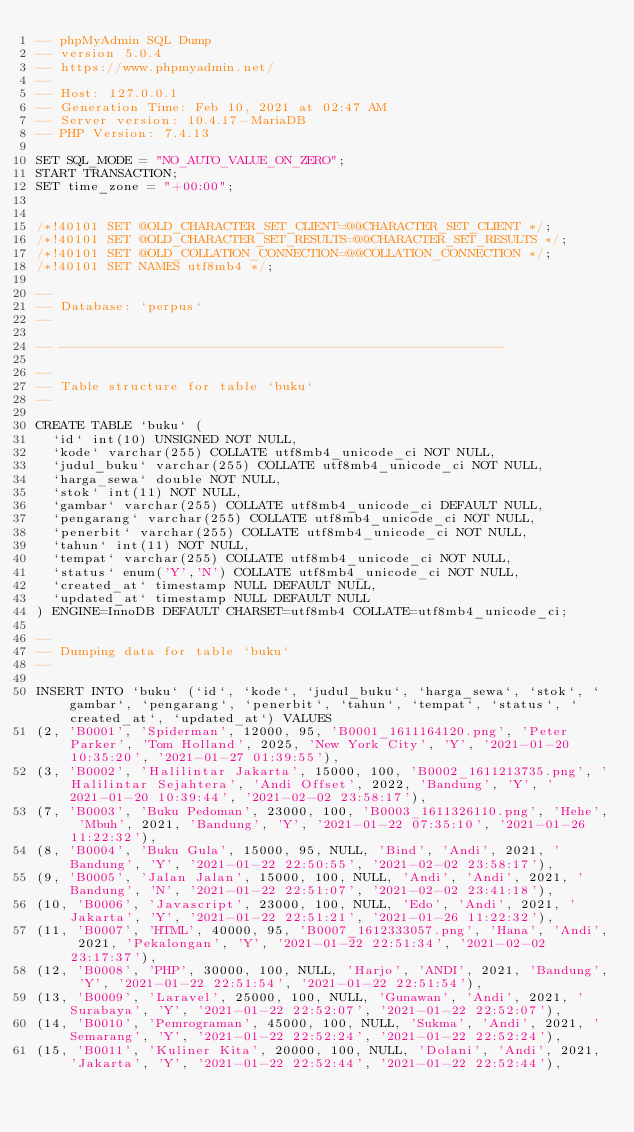Convert code to text. <code><loc_0><loc_0><loc_500><loc_500><_SQL_>-- phpMyAdmin SQL Dump
-- version 5.0.4
-- https://www.phpmyadmin.net/
--
-- Host: 127.0.0.1
-- Generation Time: Feb 10, 2021 at 02:47 AM
-- Server version: 10.4.17-MariaDB
-- PHP Version: 7.4.13

SET SQL_MODE = "NO_AUTO_VALUE_ON_ZERO";
START TRANSACTION;
SET time_zone = "+00:00";


/*!40101 SET @OLD_CHARACTER_SET_CLIENT=@@CHARACTER_SET_CLIENT */;
/*!40101 SET @OLD_CHARACTER_SET_RESULTS=@@CHARACTER_SET_RESULTS */;
/*!40101 SET @OLD_COLLATION_CONNECTION=@@COLLATION_CONNECTION */;
/*!40101 SET NAMES utf8mb4 */;

--
-- Database: `perpus`
--

-- --------------------------------------------------------

--
-- Table structure for table `buku`
--

CREATE TABLE `buku` (
  `id` int(10) UNSIGNED NOT NULL,
  `kode` varchar(255) COLLATE utf8mb4_unicode_ci NOT NULL,
  `judul_buku` varchar(255) COLLATE utf8mb4_unicode_ci NOT NULL,
  `harga_sewa` double NOT NULL,
  `stok` int(11) NOT NULL,
  `gambar` varchar(255) COLLATE utf8mb4_unicode_ci DEFAULT NULL,
  `pengarang` varchar(255) COLLATE utf8mb4_unicode_ci NOT NULL,
  `penerbit` varchar(255) COLLATE utf8mb4_unicode_ci NOT NULL,
  `tahun` int(11) NOT NULL,
  `tempat` varchar(255) COLLATE utf8mb4_unicode_ci NOT NULL,
  `status` enum('Y','N') COLLATE utf8mb4_unicode_ci NOT NULL,
  `created_at` timestamp NULL DEFAULT NULL,
  `updated_at` timestamp NULL DEFAULT NULL
) ENGINE=InnoDB DEFAULT CHARSET=utf8mb4 COLLATE=utf8mb4_unicode_ci;

--
-- Dumping data for table `buku`
--

INSERT INTO `buku` (`id`, `kode`, `judul_buku`, `harga_sewa`, `stok`, `gambar`, `pengarang`, `penerbit`, `tahun`, `tempat`, `status`, `created_at`, `updated_at`) VALUES
(2, 'B0001', 'Spiderman', 12000, 95, 'B0001_1611164120.png', 'Peter Parker', 'Tom Holland', 2025, 'New York City', 'Y', '2021-01-20 10:35:20', '2021-01-27 01:39:55'),
(3, 'B0002', 'Halilintar Jakarta', 15000, 100, 'B0002_1611213735.png', 'Halilintar Sejahtera', 'Andi Offset', 2022, 'Bandung', 'Y', '2021-01-20 10:39:44', '2021-02-02 23:58:17'),
(7, 'B0003', 'Buku Pedoman', 23000, 100, 'B0003_1611326110.png', 'Hehe', 'Mbuh', 2021, 'Bandung', 'Y', '2021-01-22 07:35:10', '2021-01-26 11:22:32'),
(8, 'B0004', 'Buku Gula', 15000, 95, NULL, 'Bind', 'Andi', 2021, 'Bandung', 'Y', '2021-01-22 22:50:55', '2021-02-02 23:58:17'),
(9, 'B0005', 'Jalan Jalan', 15000, 100, NULL, 'Andi', 'Andi', 2021, 'Bandung', 'N', '2021-01-22 22:51:07', '2021-02-02 23:41:18'),
(10, 'B0006', 'Javascript', 23000, 100, NULL, 'Edo', 'Andi', 2021, 'Jakarta', 'Y', '2021-01-22 22:51:21', '2021-01-26 11:22:32'),
(11, 'B0007', 'HTML', 40000, 95, 'B0007_1612333057.png', 'Hana', 'Andi', 2021, 'Pekalongan', 'Y', '2021-01-22 22:51:34', '2021-02-02 23:17:37'),
(12, 'B0008', 'PHP', 30000, 100, NULL, 'Harjo', 'ANDI', 2021, 'Bandung', 'Y', '2021-01-22 22:51:54', '2021-01-22 22:51:54'),
(13, 'B0009', 'Laravel', 25000, 100, NULL, 'Gunawan', 'Andi', 2021, 'Surabaya', 'Y', '2021-01-22 22:52:07', '2021-01-22 22:52:07'),
(14, 'B0010', 'Pemrograman', 45000, 100, NULL, 'Sukma', 'Andi', 2021, 'Semarang', 'Y', '2021-01-22 22:52:24', '2021-01-22 22:52:24'),
(15, 'B0011', 'Kuliner Kita', 20000, 100, NULL, 'Dolani', 'Andi', 2021, 'Jakarta', 'Y', '2021-01-22 22:52:44', '2021-01-22 22:52:44'),</code> 